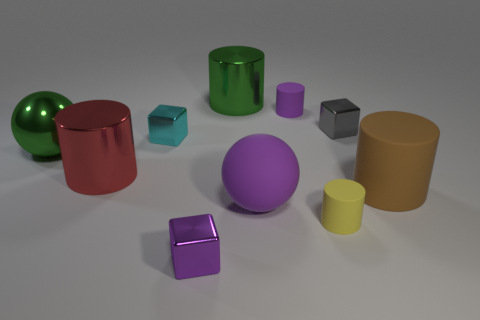Subtract all small purple blocks. How many blocks are left? 2 Subtract all cyan blocks. How many blocks are left? 2 Subtract 2 cubes. How many cubes are left? 1 Subtract all spheres. How many objects are left? 8 Subtract all purple cylinders. How many gray blocks are left? 1 Subtract all purple spheres. Subtract all green cylinders. How many objects are left? 8 Add 8 tiny gray metal things. How many tiny gray metal things are left? 9 Add 1 yellow things. How many yellow things exist? 2 Subtract 0 gray balls. How many objects are left? 10 Subtract all purple spheres. Subtract all yellow cubes. How many spheres are left? 1 